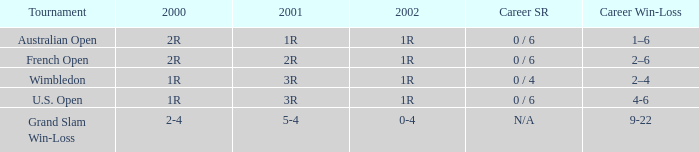In what year 2000 tournment did Angeles Montolio have a career win-loss record of 2-4? Grand Slam Win-Loss. 